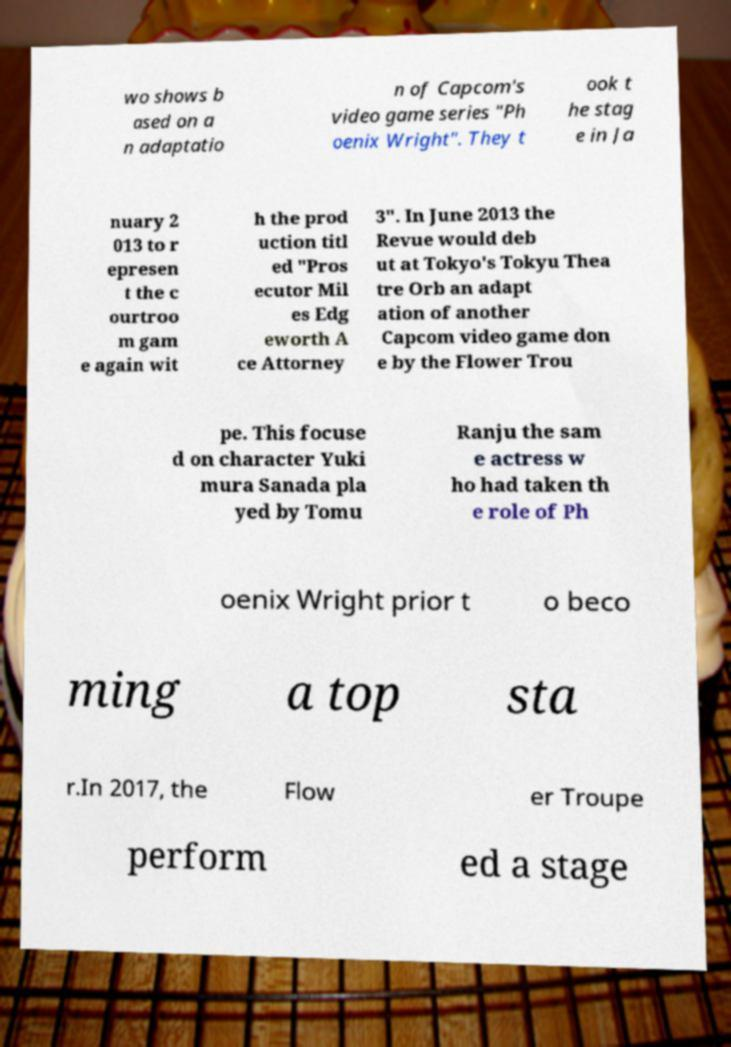What messages or text are displayed in this image? I need them in a readable, typed format. wo shows b ased on a n adaptatio n of Capcom's video game series "Ph oenix Wright". They t ook t he stag e in Ja nuary 2 013 to r epresen t the c ourtroo m gam e again wit h the prod uction titl ed "Pros ecutor Mil es Edg eworth A ce Attorney 3". In June 2013 the Revue would deb ut at Tokyo's Tokyu Thea tre Orb an adapt ation of another Capcom video game don e by the Flower Trou pe. This focuse d on character Yuki mura Sanada pla yed by Tomu Ranju the sam e actress w ho had taken th e role of Ph oenix Wright prior t o beco ming a top sta r.In 2017, the Flow er Troupe perform ed a stage 